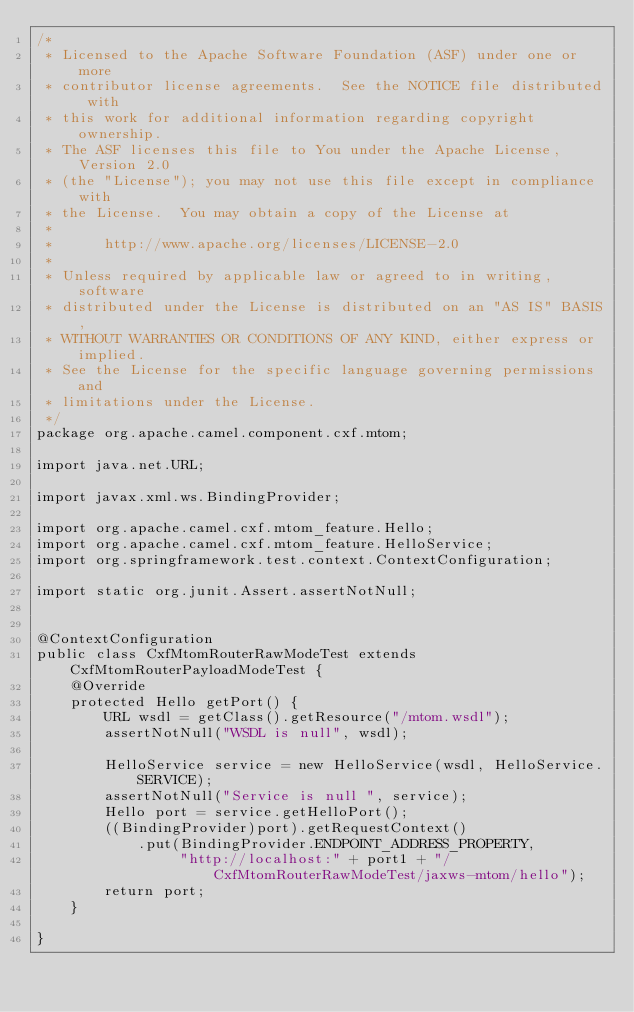Convert code to text. <code><loc_0><loc_0><loc_500><loc_500><_Java_>/*
 * Licensed to the Apache Software Foundation (ASF) under one or more
 * contributor license agreements.  See the NOTICE file distributed with
 * this work for additional information regarding copyright ownership.
 * The ASF licenses this file to You under the Apache License, Version 2.0
 * (the "License"); you may not use this file except in compliance with
 * the License.  You may obtain a copy of the License at
 *
 *      http://www.apache.org/licenses/LICENSE-2.0
 *
 * Unless required by applicable law or agreed to in writing, software
 * distributed under the License is distributed on an "AS IS" BASIS,
 * WITHOUT WARRANTIES OR CONDITIONS OF ANY KIND, either express or implied.
 * See the License for the specific language governing permissions and
 * limitations under the License.
 */
package org.apache.camel.component.cxf.mtom;

import java.net.URL;

import javax.xml.ws.BindingProvider;

import org.apache.camel.cxf.mtom_feature.Hello;
import org.apache.camel.cxf.mtom_feature.HelloService;
import org.springframework.test.context.ContextConfiguration;

import static org.junit.Assert.assertNotNull;


@ContextConfiguration
public class CxfMtomRouterRawModeTest extends CxfMtomRouterPayloadModeTest {
    @Override
    protected Hello getPort() {
        URL wsdl = getClass().getResource("/mtom.wsdl");
        assertNotNull("WSDL is null", wsdl);

        HelloService service = new HelloService(wsdl, HelloService.SERVICE);
        assertNotNull("Service is null ", service);
        Hello port = service.getHelloPort();
        ((BindingProvider)port).getRequestContext()
            .put(BindingProvider.ENDPOINT_ADDRESS_PROPERTY,
                 "http://localhost:" + port1 + "/CxfMtomRouterRawModeTest/jaxws-mtom/hello");
        return port;
    }

}
</code> 